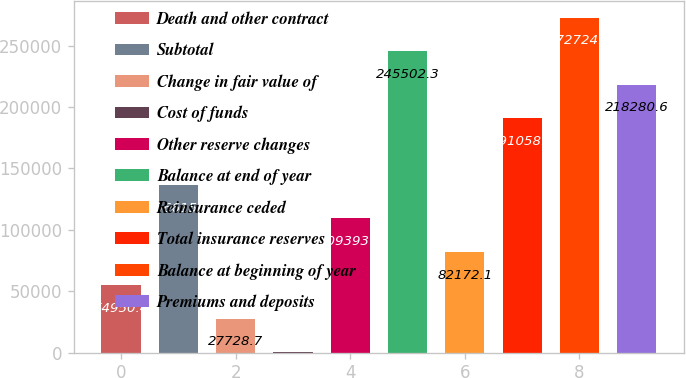<chart> <loc_0><loc_0><loc_500><loc_500><bar_chart><fcel>Death and other contract<fcel>Subtotal<fcel>Change in fair value of<fcel>Cost of funds<fcel>Other reserve changes<fcel>Balance at end of year<fcel>Reinsurance ceded<fcel>Total insurance reserves<fcel>Balance at beginning of year<fcel>Premiums and deposits<nl><fcel>54950.4<fcel>136616<fcel>27728.7<fcel>507<fcel>109394<fcel>245502<fcel>82172.1<fcel>191059<fcel>272724<fcel>218281<nl></chart> 